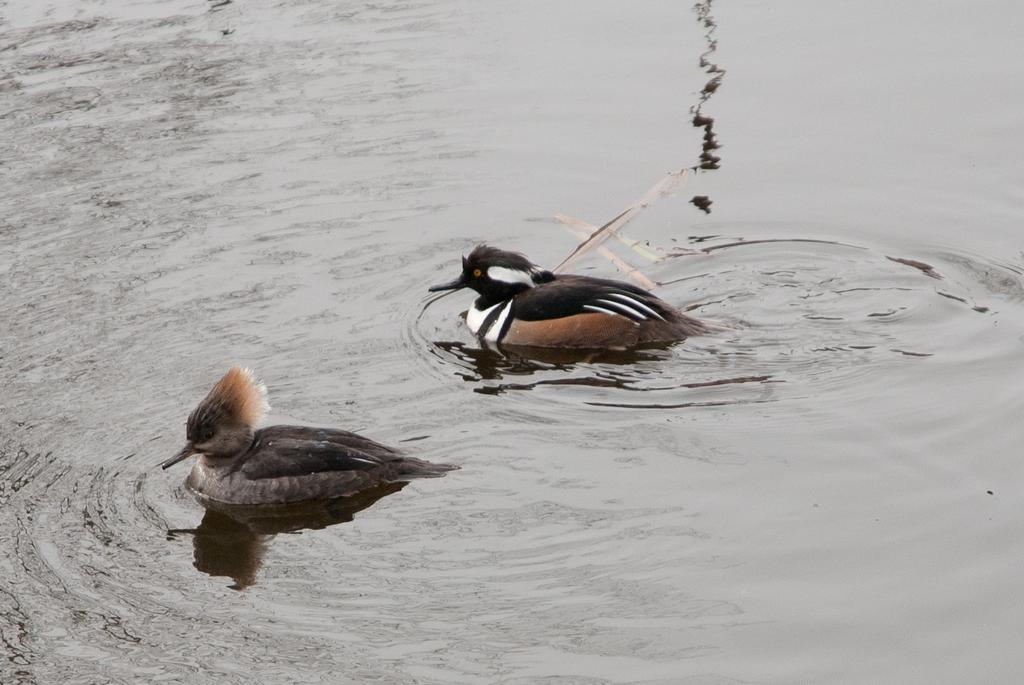How many birds are present in the image? There are two birds in the image. What are the birds doing in the image? The birds are swimming in the water. What can be seen in the background of the image? There is water visible in the background of the image. What type of bushes can be seen near the birds in the image? There are no bushes present in the image; it features two birds swimming in the water. How many cars are visible in the image? There are no cars present in the image. 